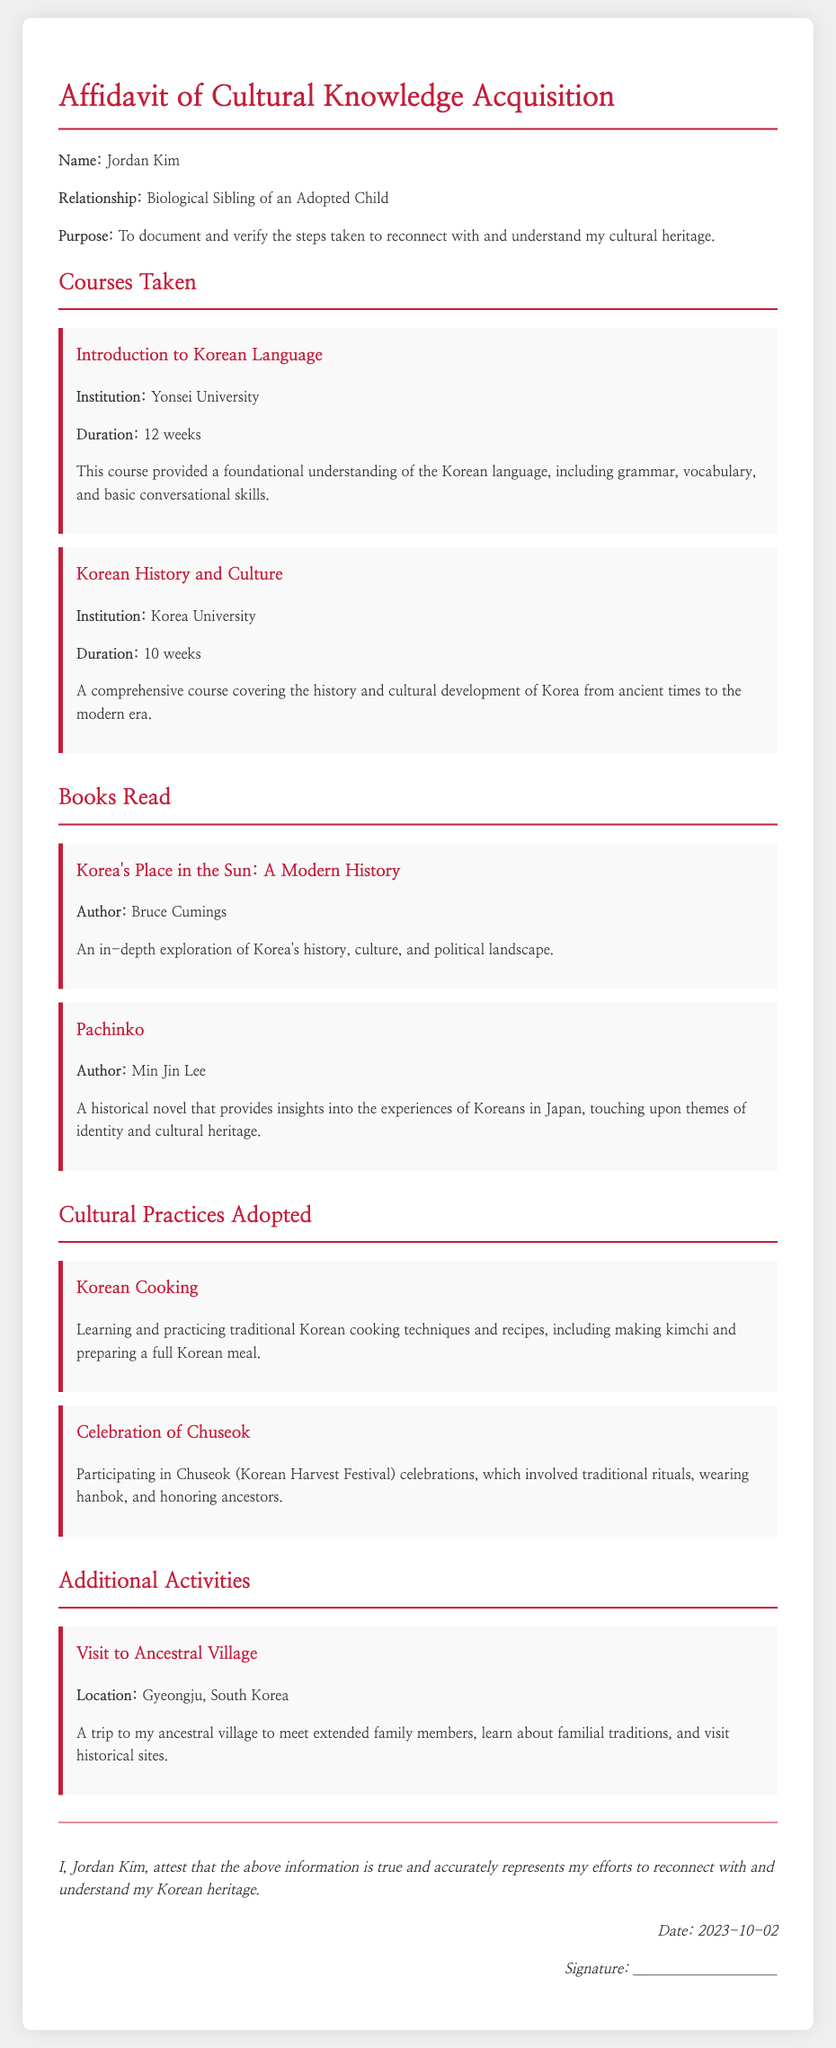What is the name of the individual making the affidavit? The name is specified in the document as Jordan Kim.
Answer: Jordan Kim What is the relationship of Jordan Kim to the adopted child? The document states that Jordan Kim is the biological sibling of an adopted child.
Answer: Biological Sibling What course did Jordan Kim take at Yonsei University? The document details the course taken at Yonsei University as Introduction to Korean Language.
Answer: Introduction to Korean Language How long did the Korean History and Culture course last? The duration of the Korean History and Culture course is mentioned as 10 weeks in the document.
Answer: 10 weeks Which book read discusses Korea's political landscape? The document refers to Korea's Place in the Sun: A Modern History as discussing Korea's political landscape.
Answer: Korea's Place in the Sun: A Modern History What cultural practice involves learning traditional Korean cooking? The document identifies Korean Cooking as a cultural practice adopted by Jordan Kim.
Answer: Korean Cooking Which festival does Jordan Kim celebrate that honors ancestors? The document indicates the celebration of Chuseok as the festival that honors ancestors.
Answer: Chuseok What is the location of the ancestral village visited? The document specifies Gyeongju, South Korea, as the location of the ancestral village.
Answer: Gyeongju, South Korea What is the purpose of this affidavit? The document states that the purpose is to document and verify the steps taken to reconnect with and understand cultural heritage.
Answer: To document and verify steps taken to reconnect with and understand cultural heritage 